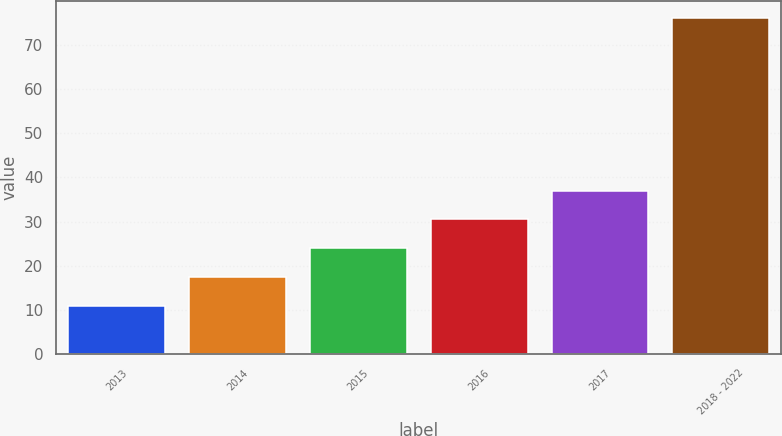<chart> <loc_0><loc_0><loc_500><loc_500><bar_chart><fcel>2013<fcel>2014<fcel>2015<fcel>2016<fcel>2017<fcel>2018 - 2022<nl><fcel>11<fcel>17.5<fcel>24<fcel>30.5<fcel>37<fcel>76<nl></chart> 